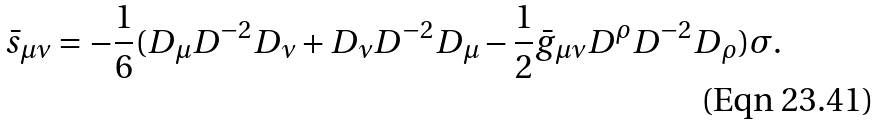<formula> <loc_0><loc_0><loc_500><loc_500>\bar { s } _ { \mu \nu } = - \frac { 1 } { 6 } ( D _ { \mu } D ^ { - 2 } D _ { \nu } + D _ { \nu } D ^ { - 2 } D _ { \mu } - \frac { 1 } { 2 } \bar { g } _ { \mu \nu } D ^ { \rho } D ^ { - 2 } D _ { \rho } ) \sigma .</formula> 